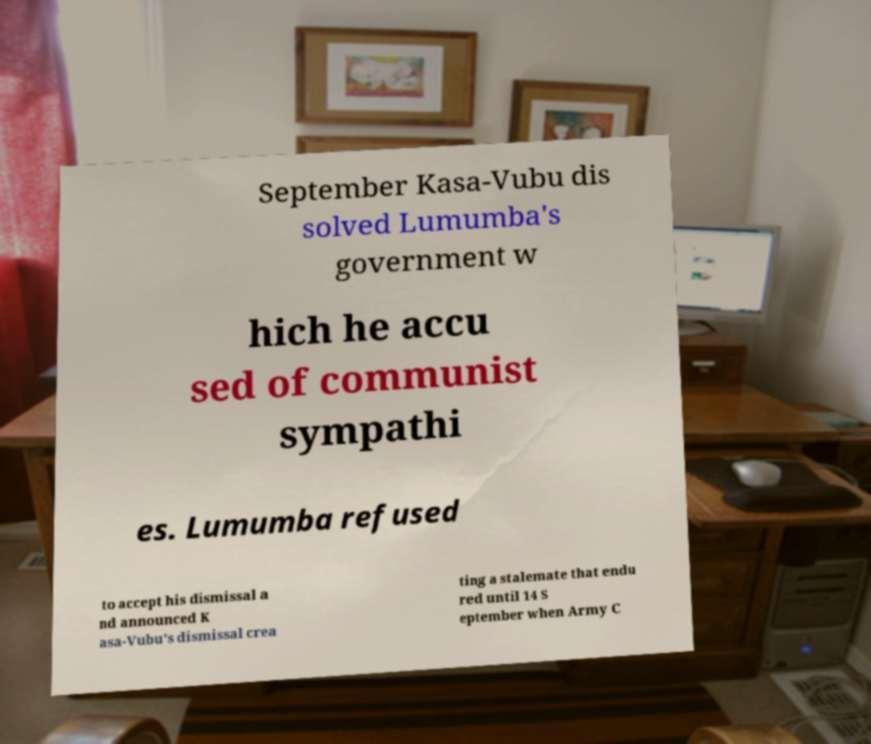Could you extract and type out the text from this image? September Kasa-Vubu dis solved Lumumba's government w hich he accu sed of communist sympathi es. Lumumba refused to accept his dismissal a nd announced K asa-Vubu's dismissal crea ting a stalemate that endu red until 14 S eptember when Army C 